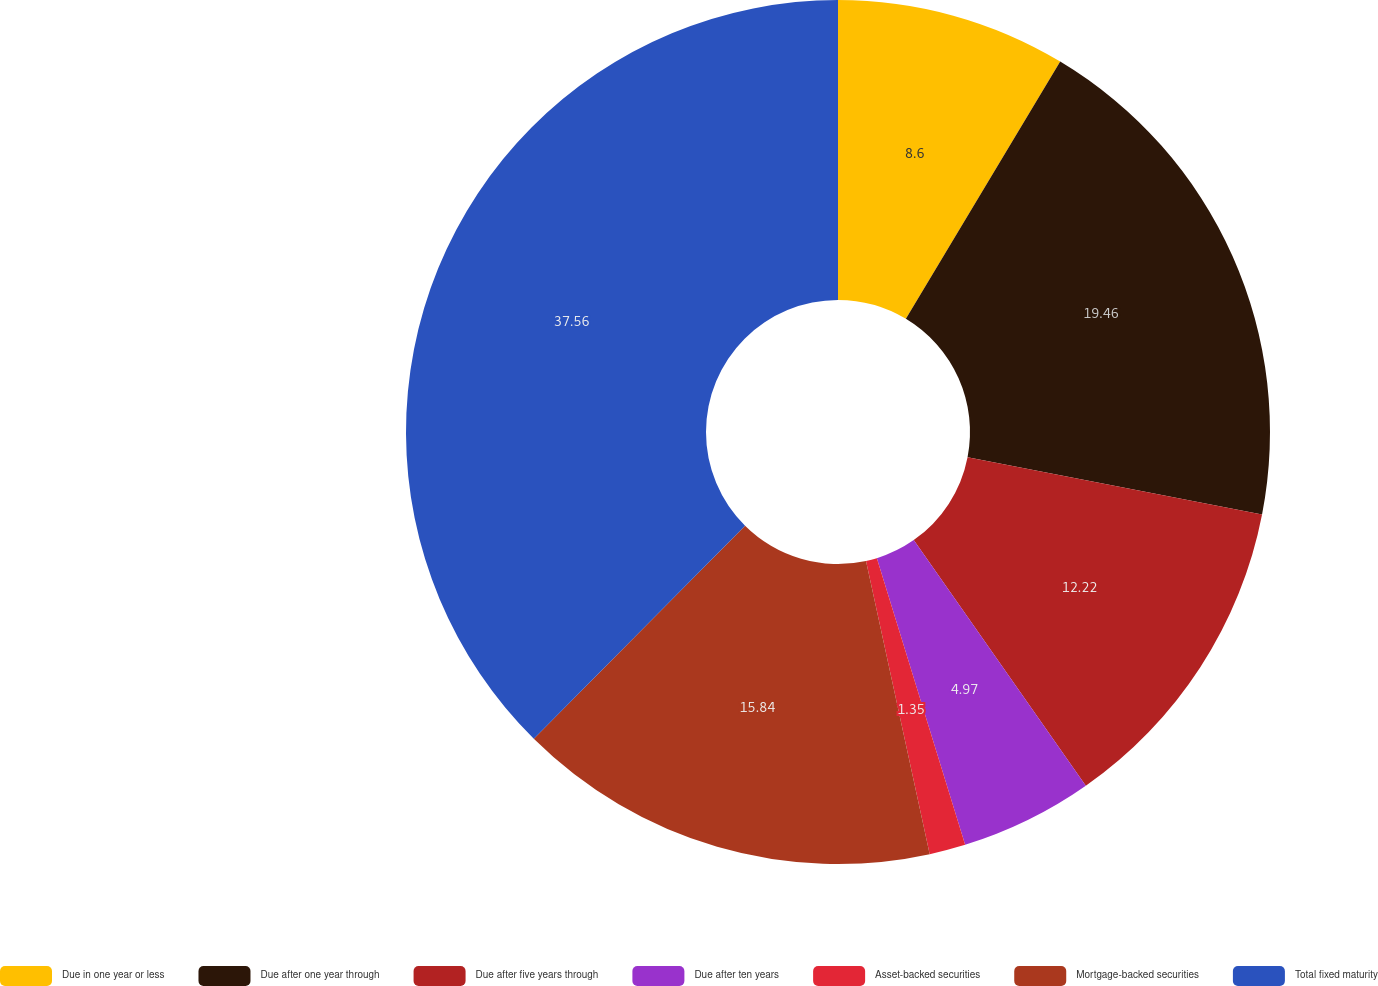Convert chart. <chart><loc_0><loc_0><loc_500><loc_500><pie_chart><fcel>Due in one year or less<fcel>Due after one year through<fcel>Due after five years through<fcel>Due after ten years<fcel>Asset-backed securities<fcel>Mortgage-backed securities<fcel>Total fixed maturity<nl><fcel>8.6%<fcel>19.46%<fcel>12.22%<fcel>4.97%<fcel>1.35%<fcel>15.84%<fcel>37.57%<nl></chart> 